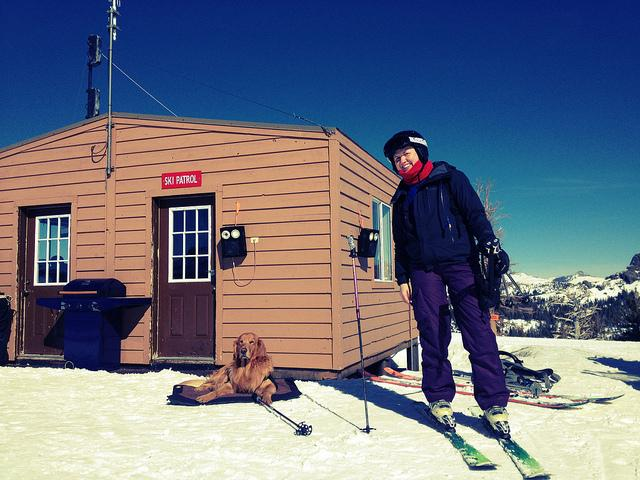What type of sign is on the building? Please explain your reasoning. informational. The sign says "ski patrol" and is directly over the exterior entrance to the building. 